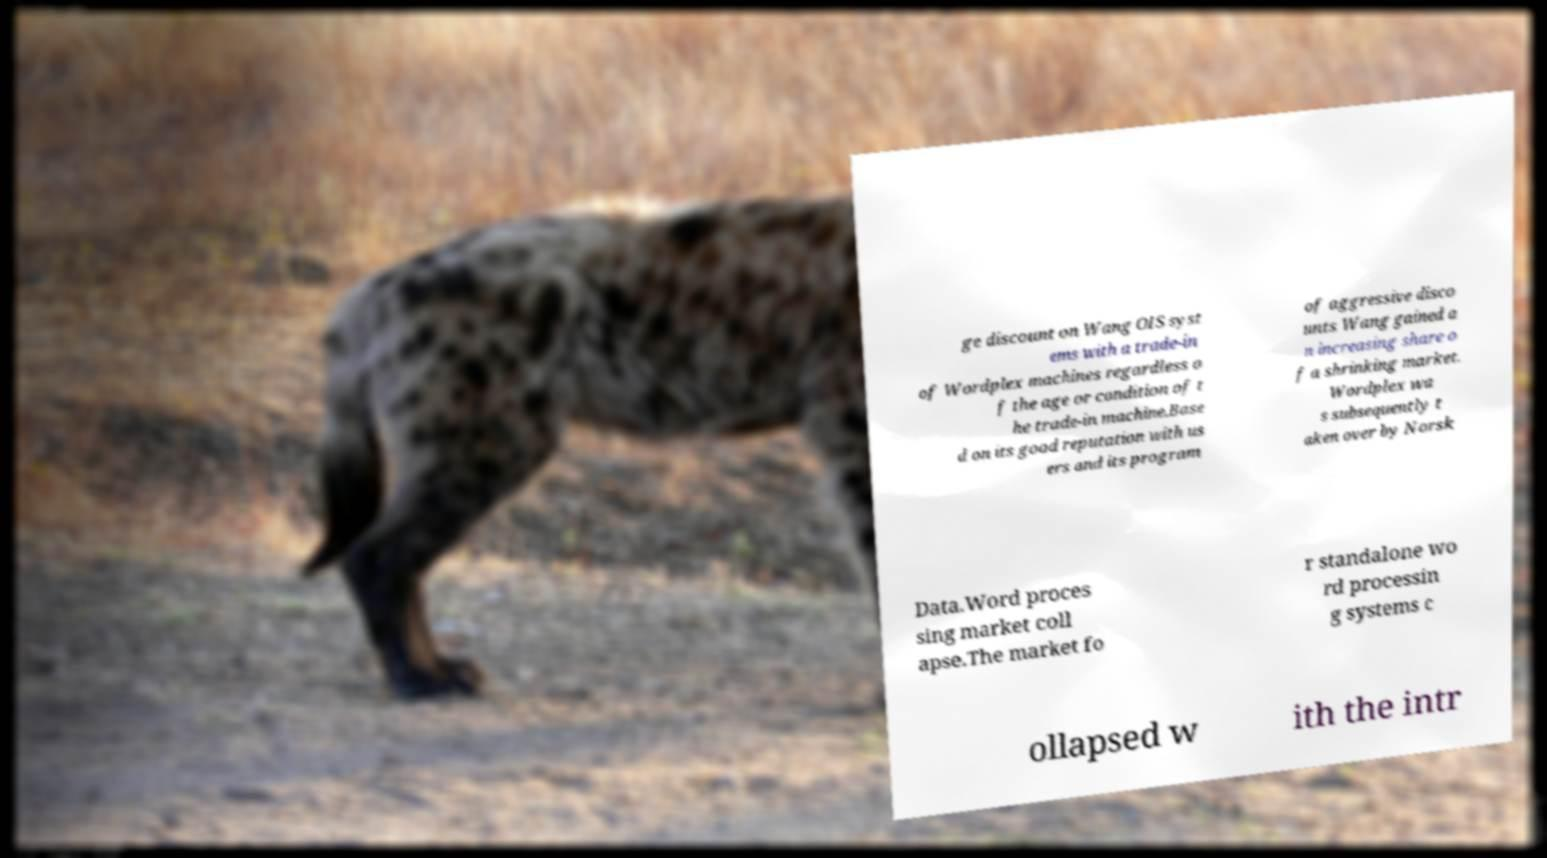Could you assist in decoding the text presented in this image and type it out clearly? ge discount on Wang OIS syst ems with a trade-in of Wordplex machines regardless o f the age or condition of t he trade-in machine.Base d on its good reputation with us ers and its program of aggressive disco unts Wang gained a n increasing share o f a shrinking market. Wordplex wa s subsequently t aken over by Norsk Data.Word proces sing market coll apse.The market fo r standalone wo rd processin g systems c ollapsed w ith the intr 